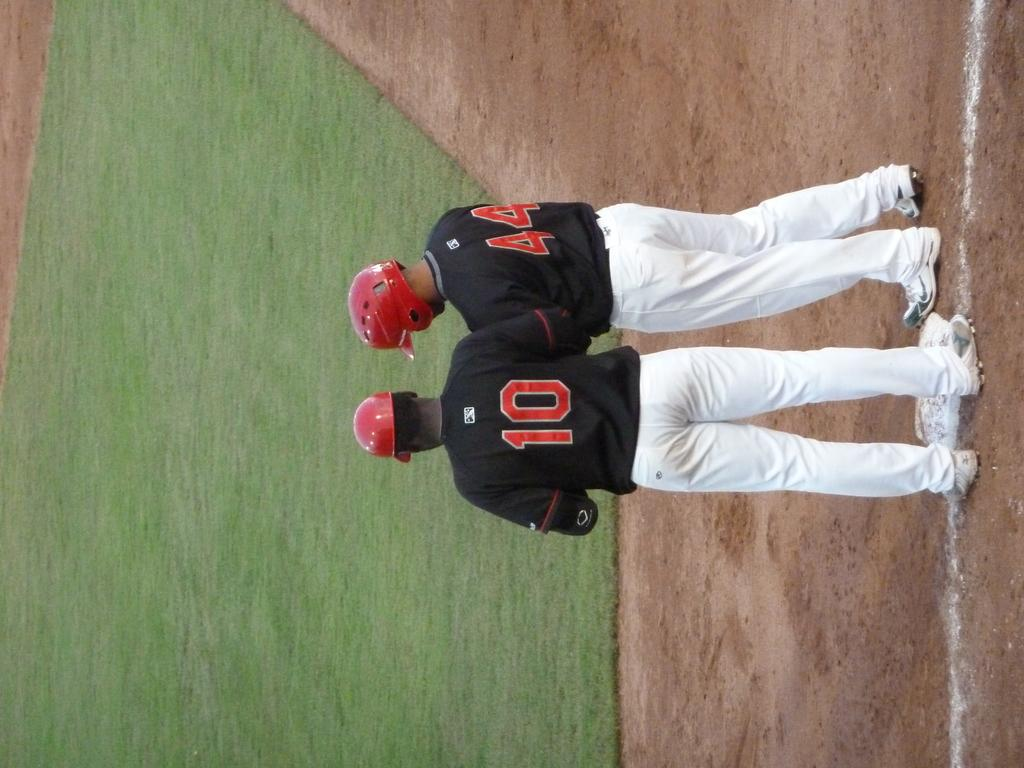<image>
Summarize the visual content of the image. Two baseball players wearing black tops and white pants numbered ten and fourty four chat on the baseball field. 